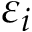<formula> <loc_0><loc_0><loc_500><loc_500>\varepsilon _ { i }</formula> 